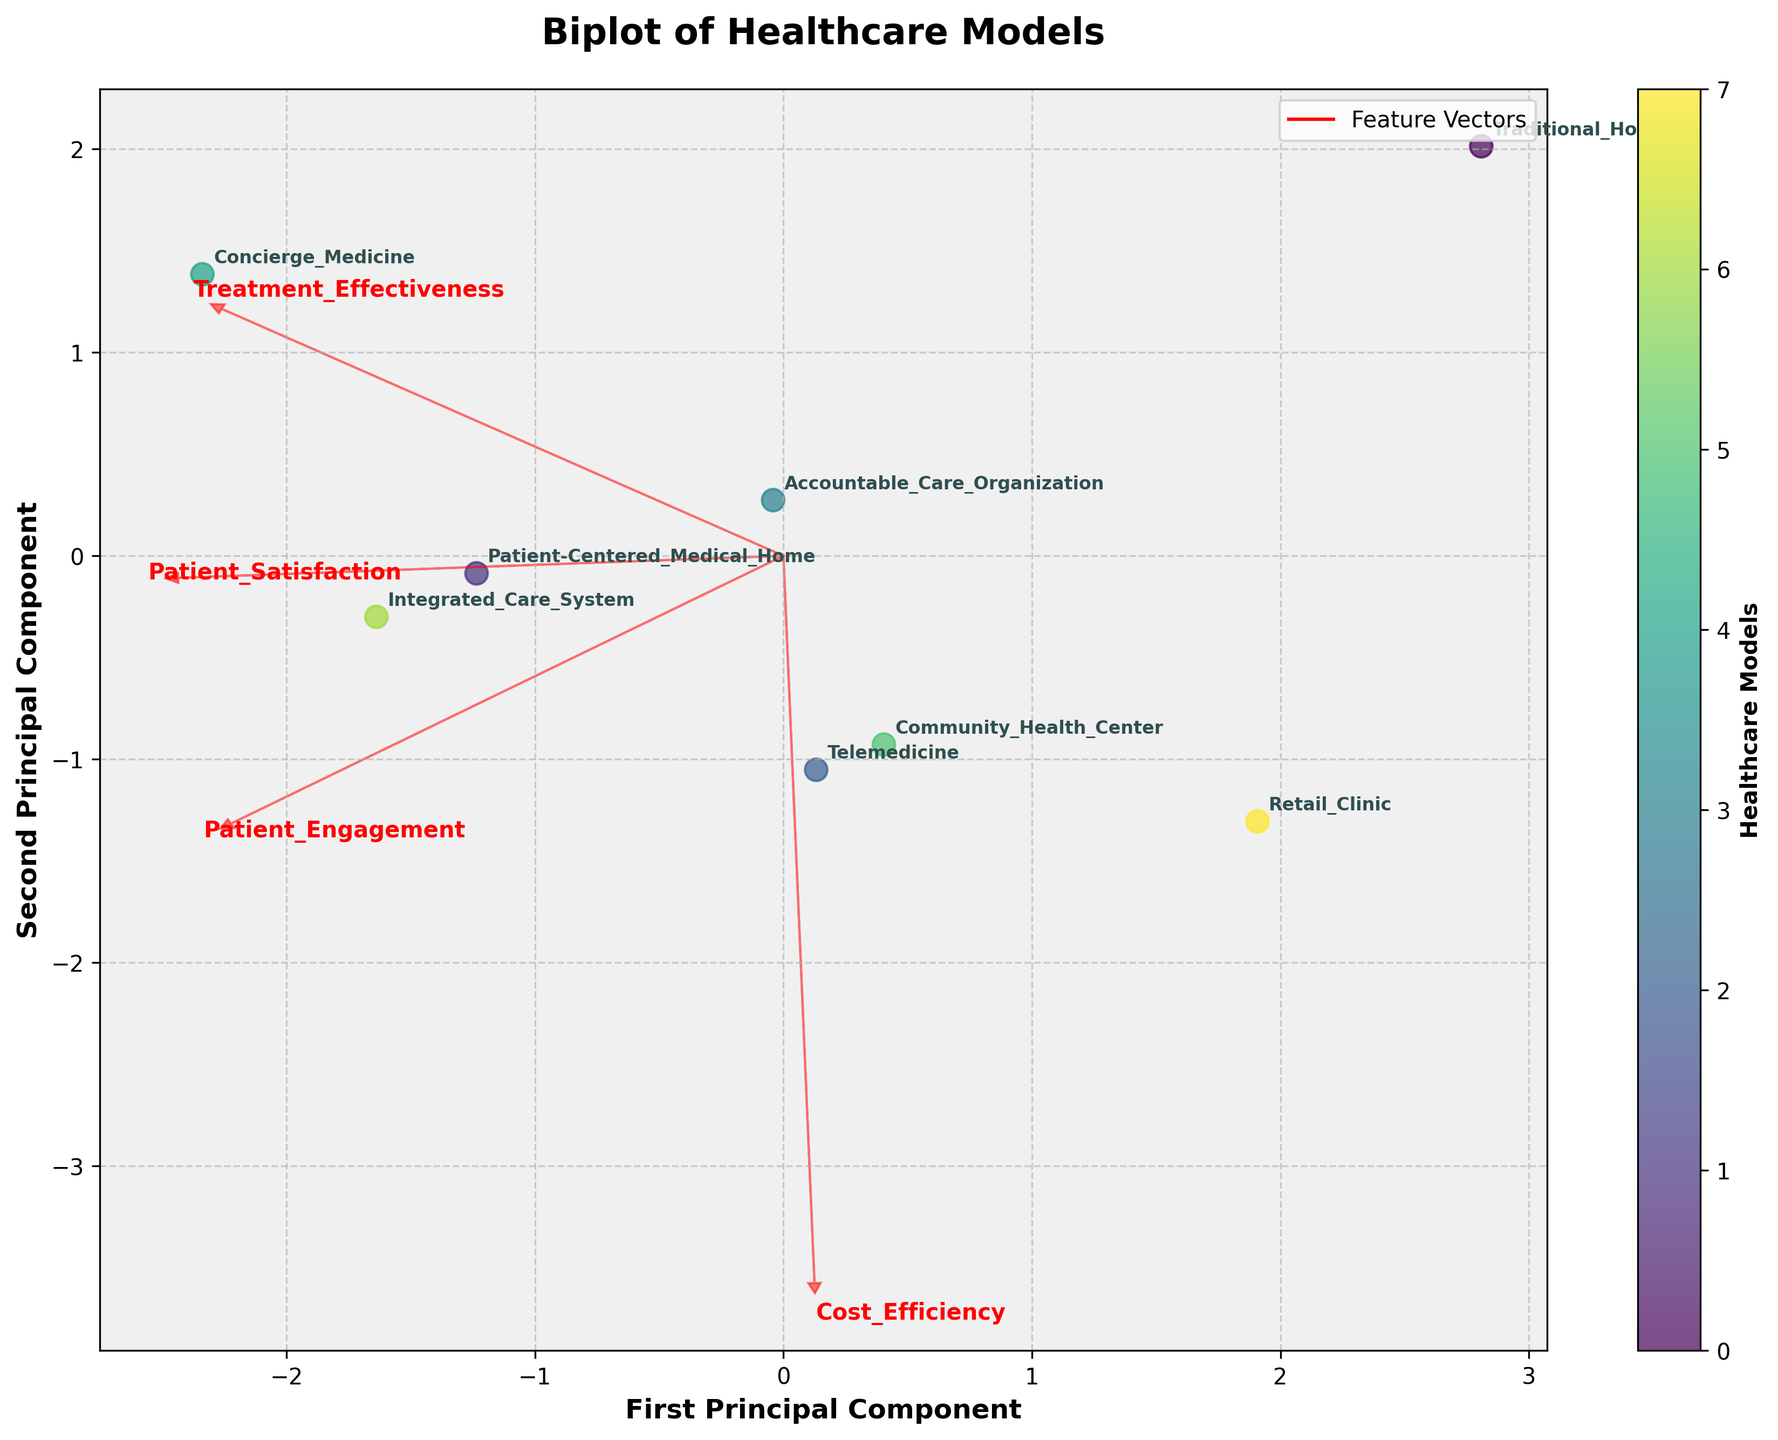What is the title of the figure? The title is usually at the top of the figure, prominently displayed and easy to read.
Answer: Biplot of Healthcare Models How many healthcare models are represented in the biplot? Each data point represents a healthcare model and is annotated with its name. By counting the labels, we can determine the number of models.
Answer: 8 Which healthcare model is the farthest to the right on the first principal component? By examining the points along the axis labeled "First Principal Component," we identify the model that is positioned the furthest to the right.
Answer: Concierge Medicine Which two healthcare models have the highest patient engagement levels based on their positions along the arrows? The feature vector arrows indicate the direction and strength of each principal component. The models closest to the arrow labeled "Patient Engagement" have the highest patient engagement.
Answer: Concierge Medicine, Integrated Care System Which model has almost the same loading on both the first and second principal components? By identifying the point that is approximately equidistant from both axes and taking note of the labeled models, we find the one with similar loadings on both components.
Answer: Patient-Centered Medical Home How is the Patient-Centered Medical Home model positioned relative to Telemedicine in terms of patient satisfaction and treatment effectiveness? Analyze the relative positions of the two models along the directions of the feature vectors "Patient Satisfaction" and "Treatment Effectiveness."
Answer: Higher on both dimensions What direction does the feature vector for Cost Efficiency point in the plot? Examine the direction of the arrow labeled "Cost Efficiency". This indicates whether it points positively or negatively along the principal components.
Answer: Upper right Are traditional hospitals more closely aligned with patient satisfaction or treatment effectiveness based on their position in the biplot? Look at the position of Traditional Hospitals relative to the feature vectors for "Patient Satisfaction" and "Treatment Effectiveness" to see which vector it is closer to.
Answer: Treatment Effectiveness Compare the position of Retail Clinics to Community Health Centers across both principal components. Which has more positive values on the second principal component? Identify their locations on the second principal component axis. The one higher up has more positive values.
Answer: Retail Clinic Which feature vector has the smallest angle with the first principal component axis? The feature vector with the smallest angle to the first principal component will be the most aligned with it. Measure the angles visually to find the smallest.
Answer: Patient Satisfaction 